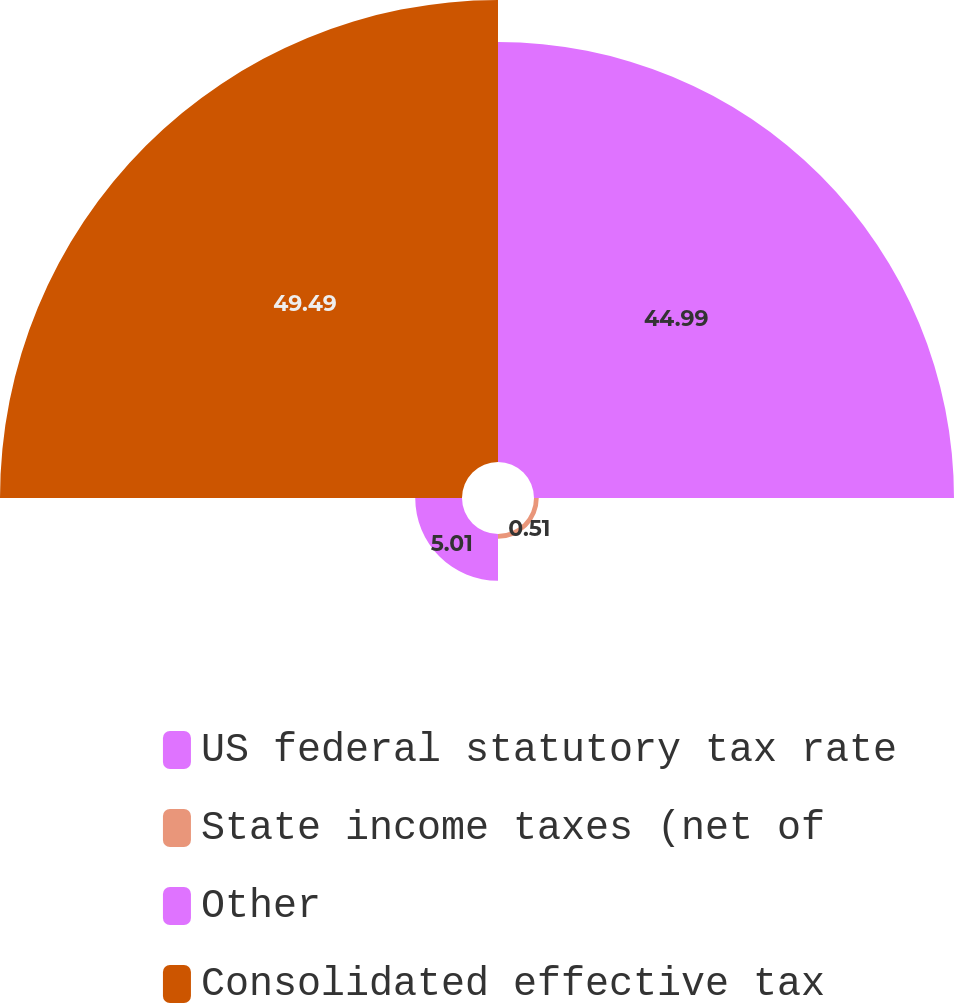Convert chart. <chart><loc_0><loc_0><loc_500><loc_500><pie_chart><fcel>US federal statutory tax rate<fcel>State income taxes (net of<fcel>Other<fcel>Consolidated effective tax<nl><fcel>44.99%<fcel>0.51%<fcel>5.01%<fcel>49.49%<nl></chart> 